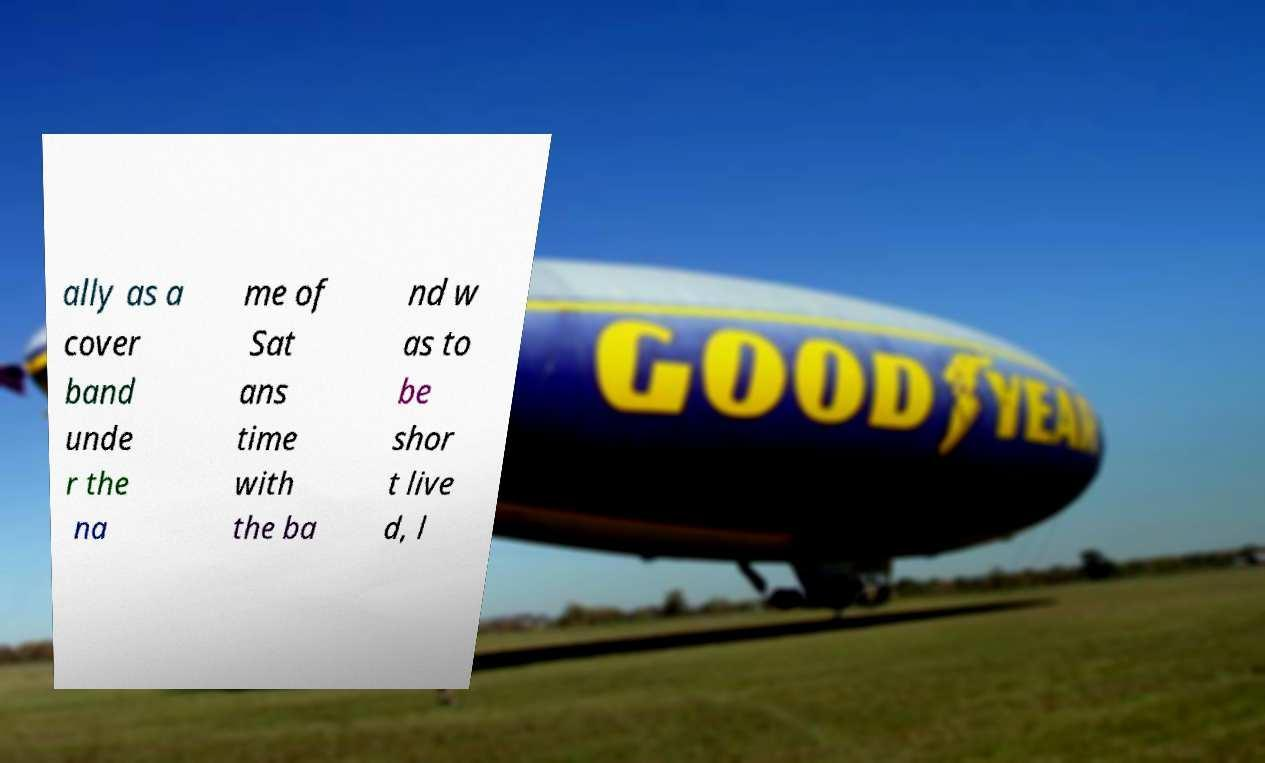Please read and relay the text visible in this image. What does it say? ally as a cover band unde r the na me of Sat ans time with the ba nd w as to be shor t live d, l 